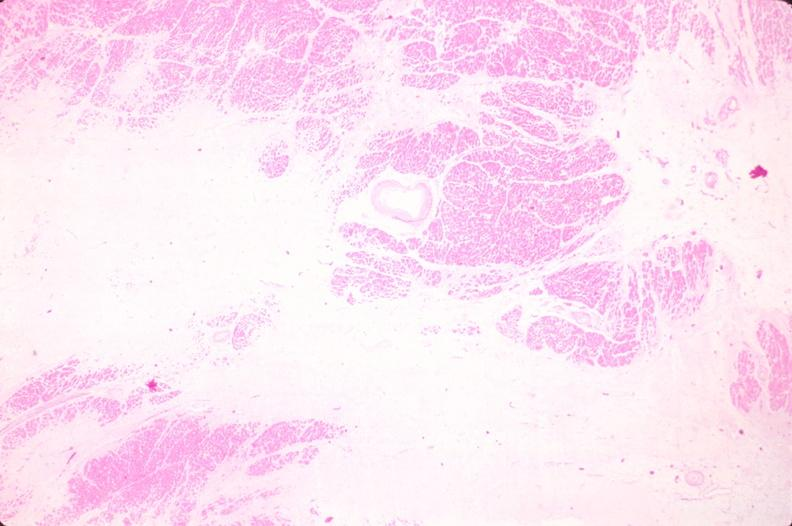where is this in?
Answer the question using a single word or phrase. In heart 